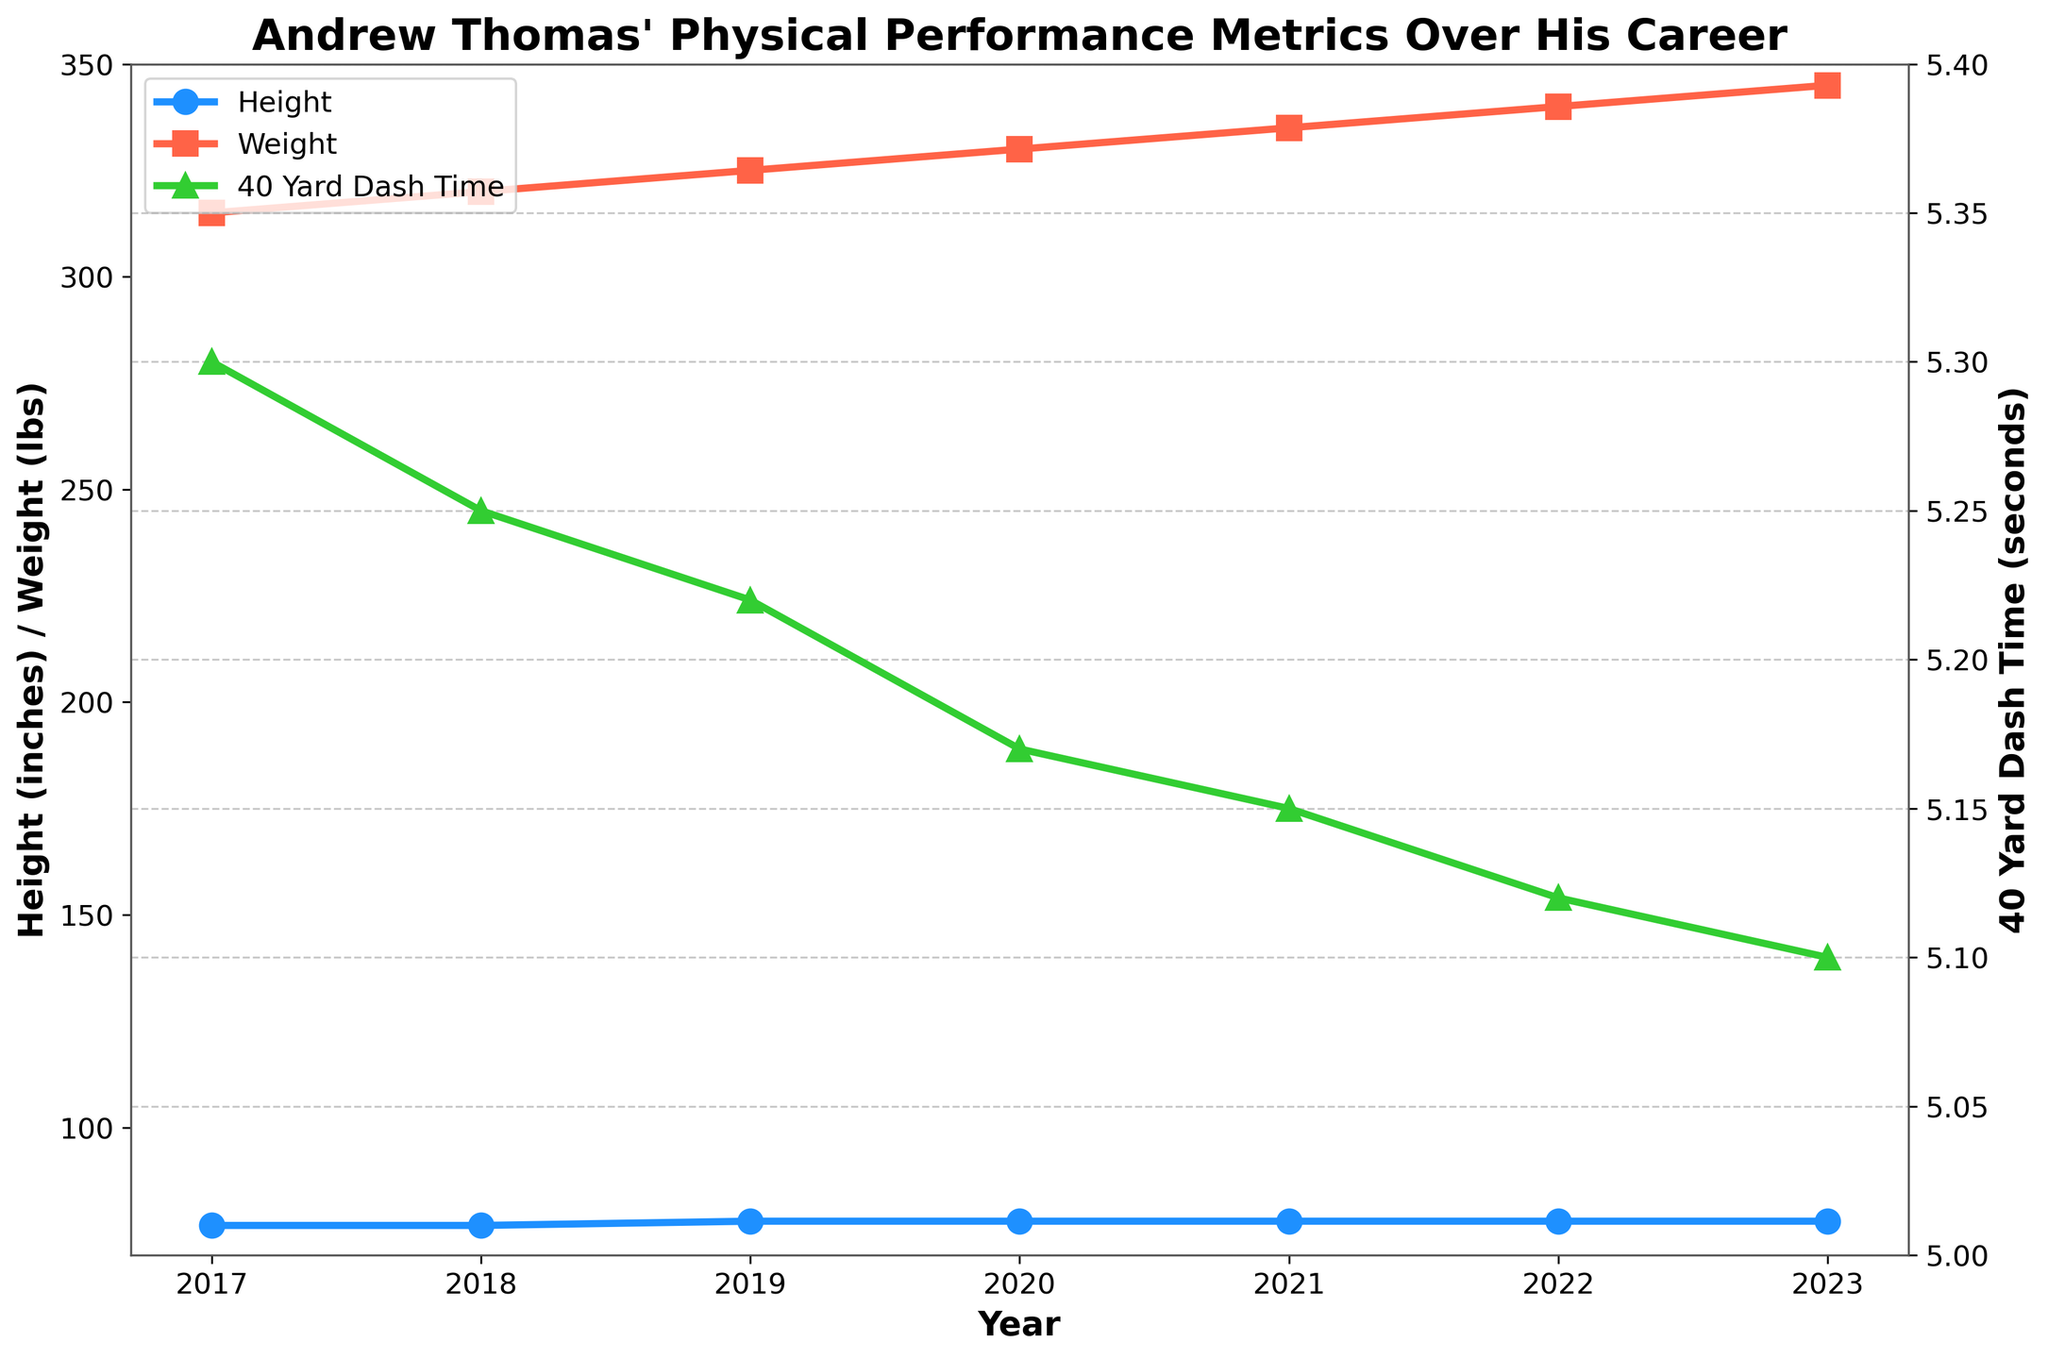What is the title of the figure? The title is usually displayed at the top of the figure, seen as a large bold text to provide context about the data visualized.
Answer: Andrew Thomas' Physical Performance Metrics Over His Career What are the units for weight on the y-axis? The units for weight are usually displayed next to the label of the y-axis where weight is plotted.
Answer: lbs What is the color used to plot the 40 Yard Dash Time? Colors for different lines are often either written in the legend or observed directly from the plot. Look for the line that represents the 40 Yard Dash Time and note its color.
Answer: Green How many years are covered on the x-axis? Count the number of distinct points (years) plotted along the x-axis.
Answer: 7 Which year marks the highest weight recorded for Andrew Thomas? Identify the highest point on the weight line and then note the corresponding year on the x-axis.
Answer: 2023 How did Andrew Thomas' 40 Yard Dash Time change from 2017 to 2023? Look for the starting point (2017) and the ending point (2023) for the 40 Yard Dash Time line and observe the trend.
Answer: Decreased By how much did Andrew Thomas' height increase from 2017 to 2019? Compare the height values at 2017 and 2019, then calculate the difference.
Answer: 1 inch What is the average weight of Andrew Thomas over the years presented? Sum all the weight values and divide by the number of years.
Answer: 330 lbs Was Andrew Thomas' weight always increasing throughout the years? Check the weight line and observe if it continuously rises every year.
Answer: Yes Which year has the smallest 40 Yard Dash Time? Identify the smallest point on the 40 Yard Dash Time line and then note the corresponding year on the x-axis.
Answer: 2023 